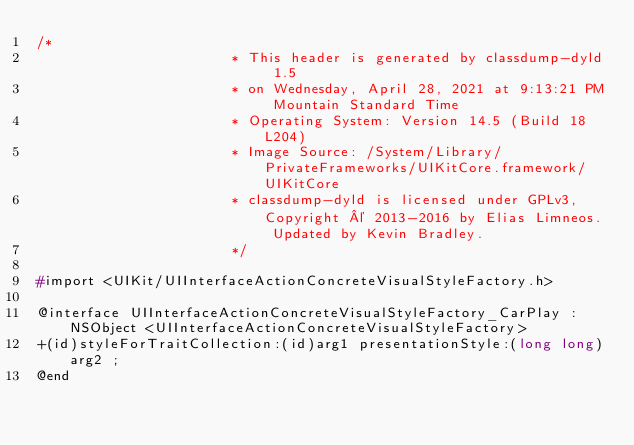<code> <loc_0><loc_0><loc_500><loc_500><_C_>/*
                       * This header is generated by classdump-dyld 1.5
                       * on Wednesday, April 28, 2021 at 9:13:21 PM Mountain Standard Time
                       * Operating System: Version 14.5 (Build 18L204)
                       * Image Source: /System/Library/PrivateFrameworks/UIKitCore.framework/UIKitCore
                       * classdump-dyld is licensed under GPLv3, Copyright © 2013-2016 by Elias Limneos. Updated by Kevin Bradley.
                       */

#import <UIKit/UIInterfaceActionConcreteVisualStyleFactory.h>

@interface UIInterfaceActionConcreteVisualStyleFactory_CarPlay : NSObject <UIInterfaceActionConcreteVisualStyleFactory>
+(id)styleForTraitCollection:(id)arg1 presentationStyle:(long long)arg2 ;
@end

</code> 